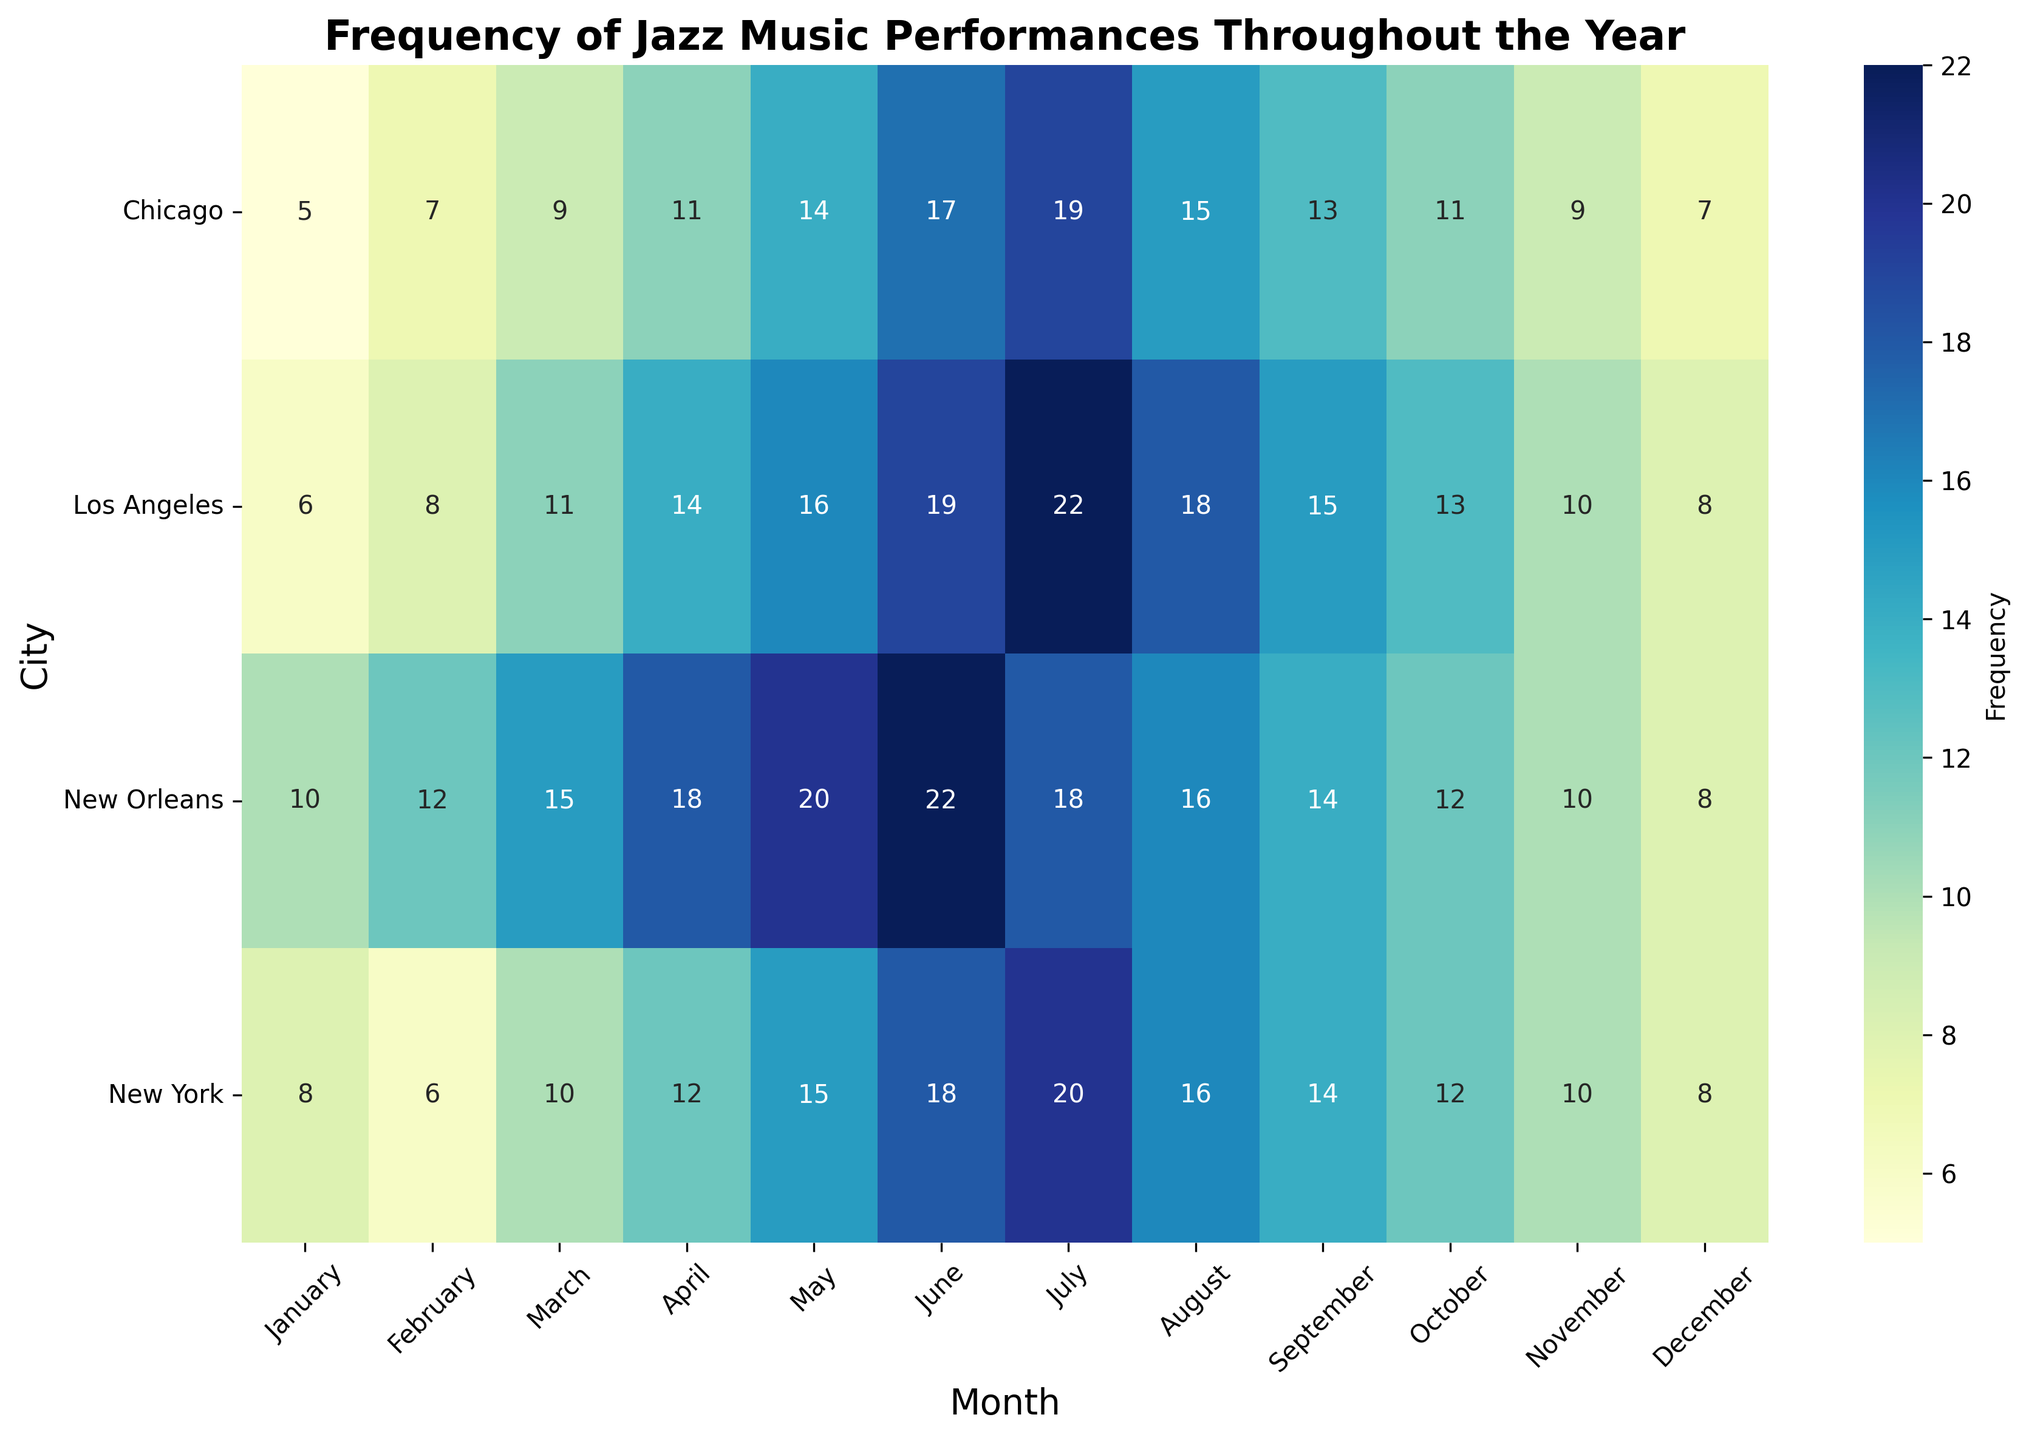Which city had the highest frequency of jazz performances in July? Look at the row corresponding to July and identify the city with the highest number. For July, New Orleans has 22 performances, which is the highest.
Answer: New Orleans Which month had the highest frequency of jazz performances in New York? Look along the row for New York to locate the highest number. July had 20 performances, which is the highest in New York.
Answer: July What is the difference in frequency of jazz performances between February and March in Chicago? Look at the cells for February and March in Chicago. February has 7 performances, and March has 9 performances. The difference is 9 - 7 = 2.
Answer: 2 Which city had the least frequency of jazz performances in December? Look at the column for December across all cities to find the lowest number. Chicago had the least with 7 performances.
Answer: Chicago What is the average frequency of jazz performances in May across all cities? Sum the values for May across all cities (15 for New York, 14 for Chicago, 16 for Los Angeles, 20 for New Orleans). Then divide by the number of cities, which is 4. (15+14+16+20)/4 = 65/4 = 16.25.
Answer: 16.25 How does the frequency of jazz performances in April compare between New Orleans and Los Angeles? Look at the values for April in both cities. New Orleans has 18 performances, and Los Angeles has 14 performances. New Orleans has more performances.
Answer: New Orleans has more Which month saw the highest total frequency of jazz performances across all cities? Sum the frequencies for each month across all cities and identify the month with the highest sum. July has the highest total with (20 (NY) + 19 (Chicago) + 22 (LA) + 18 (NO)) = 79.
Answer: July In which month did New York and Los Angeles have the same number of jazz performances? Compare the frequencies of each month for New York and Los Angeles. Both cities had 8 performances in December.
Answer: December What is the combined frequency of jazz performances in June for Chicago and New Orleans? Add the values of June for both cities. Chicago has 17, and New Orleans has 22. The sum is 17 + 22 = 39.
Answer: 39 Is there any trend in frequency of jazz performances over the months in any city, and if so, which one? Examine the frequency of performances across months for each city. New York, Chicago, and Los Angeles show an increasing trend up to July, followed by a decrease, whereas New Orleans has a more consistently high number of performances throughout the year.
Answer: New Orleans 